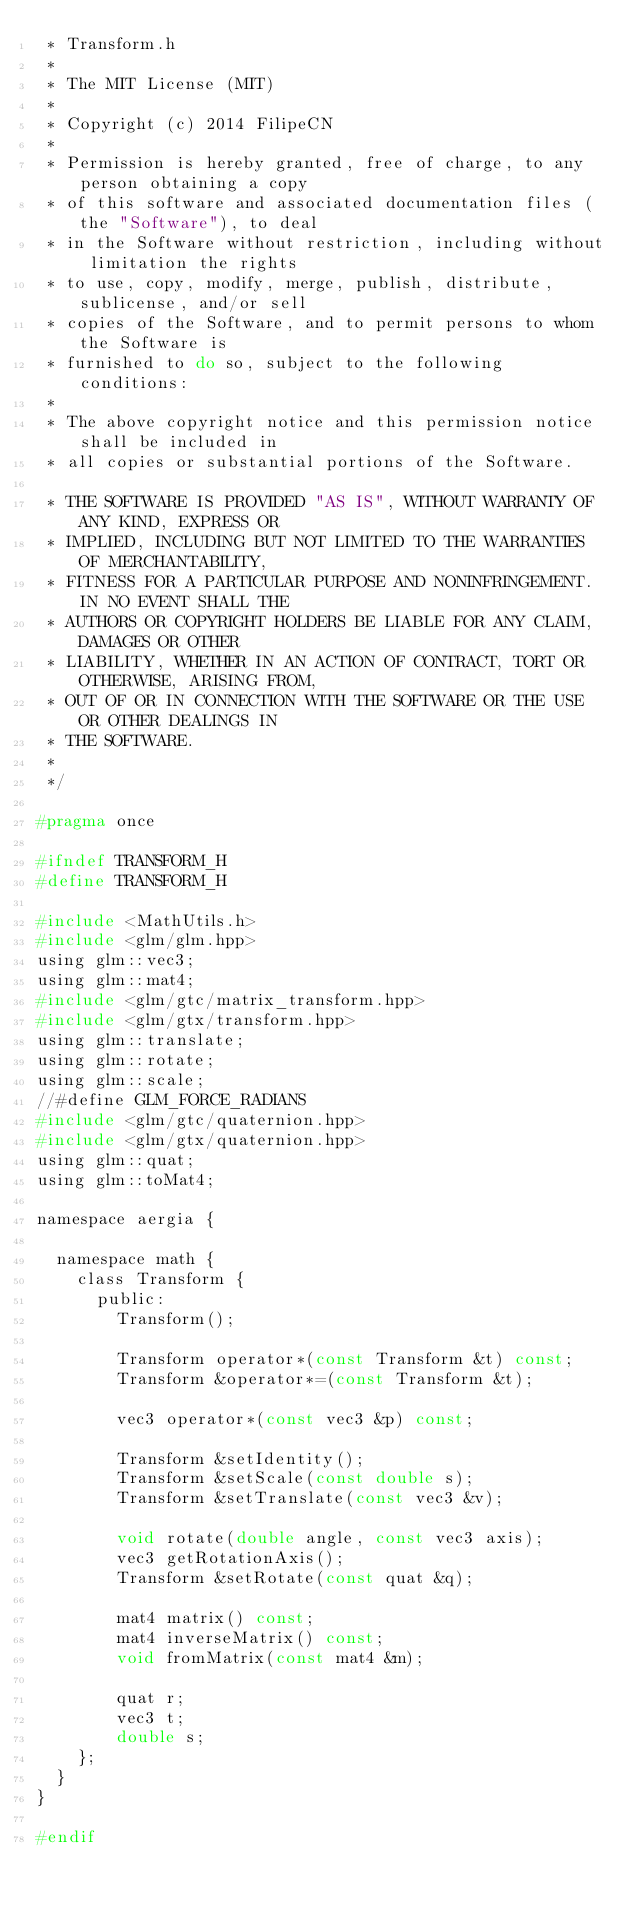<code> <loc_0><loc_0><loc_500><loc_500><_C_> * Transform.h
 *
 * The MIT License (MIT)
 *
 * Copyright (c) 2014 FilipeCN
 *
 * Permission is hereby granted, free of charge, to any person obtaining a copy
 * of this software and associated documentation files (the "Software"), to deal
 * in the Software without restriction, including without limitation the rights
 * to use, copy, modify, merge, publish, distribute, sublicense, and/or sell
 * copies of the Software, and to permit persons to whom the Software is
 * furnished to do so, subject to the following conditions:
 *
 * The above copyright notice and this permission notice shall be included in
 * all copies or substantial portions of the Software.

 * THE SOFTWARE IS PROVIDED "AS IS", WITHOUT WARRANTY OF ANY KIND, EXPRESS OR
 * IMPLIED, INCLUDING BUT NOT LIMITED TO THE WARRANTIES OF MERCHANTABILITY,
 * FITNESS FOR A PARTICULAR PURPOSE AND NONINFRINGEMENT. IN NO EVENT SHALL THE
 * AUTHORS OR COPYRIGHT HOLDERS BE LIABLE FOR ANY CLAIM, DAMAGES OR OTHER
 * LIABILITY, WHETHER IN AN ACTION OF CONTRACT, TORT OR OTHERWISE, ARISING FROM,
 * OUT OF OR IN CONNECTION WITH THE SOFTWARE OR THE USE OR OTHER DEALINGS IN
 * THE SOFTWARE.
 *
 */

#pragma once

#ifndef TRANSFORM_H
#define TRANSFORM_H

#include <MathUtils.h>
#include <glm/glm.hpp>
using glm::vec3;
using glm::mat4;
#include <glm/gtc/matrix_transform.hpp> 
#include <glm/gtx/transform.hpp>
using glm::translate;
using glm::rotate;
using glm::scale;
//#define GLM_FORCE_RADIANS
#include <glm/gtc/quaternion.hpp>
#include <glm/gtx/quaternion.hpp>
using glm::quat;
using glm::toMat4;

namespace aergia {

	namespace math {
		class Transform {
			public:
				Transform();

				Transform operator*(const Transform &t) const;
				Transform &operator*=(const Transform &t);

				vec3 operator*(const vec3 &p) const;

				Transform &setIdentity();
				Transform &setScale(const double s);
				Transform &setTranslate(const vec3 &v);

				void rotate(double angle, const vec3 axis); 
				vec3 getRotationAxis();
				Transform &setRotate(const quat &q);

				mat4 matrix() const;
				mat4 inverseMatrix() const;
				void fromMatrix(const mat4 &m);

				quat r;
				vec3 t;
				double s; 
		};
	}
}

#endif

</code> 